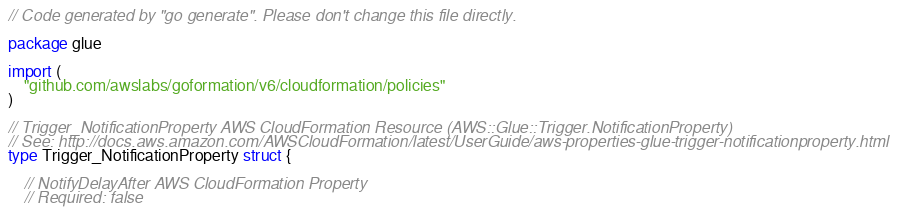<code> <loc_0><loc_0><loc_500><loc_500><_Go_>// Code generated by "go generate". Please don't change this file directly.

package glue

import (
	"github.com/awslabs/goformation/v6/cloudformation/policies"
)

// Trigger_NotificationProperty AWS CloudFormation Resource (AWS::Glue::Trigger.NotificationProperty)
// See: http://docs.aws.amazon.com/AWSCloudFormation/latest/UserGuide/aws-properties-glue-trigger-notificationproperty.html
type Trigger_NotificationProperty struct {

	// NotifyDelayAfter AWS CloudFormation Property
	// Required: false</code> 